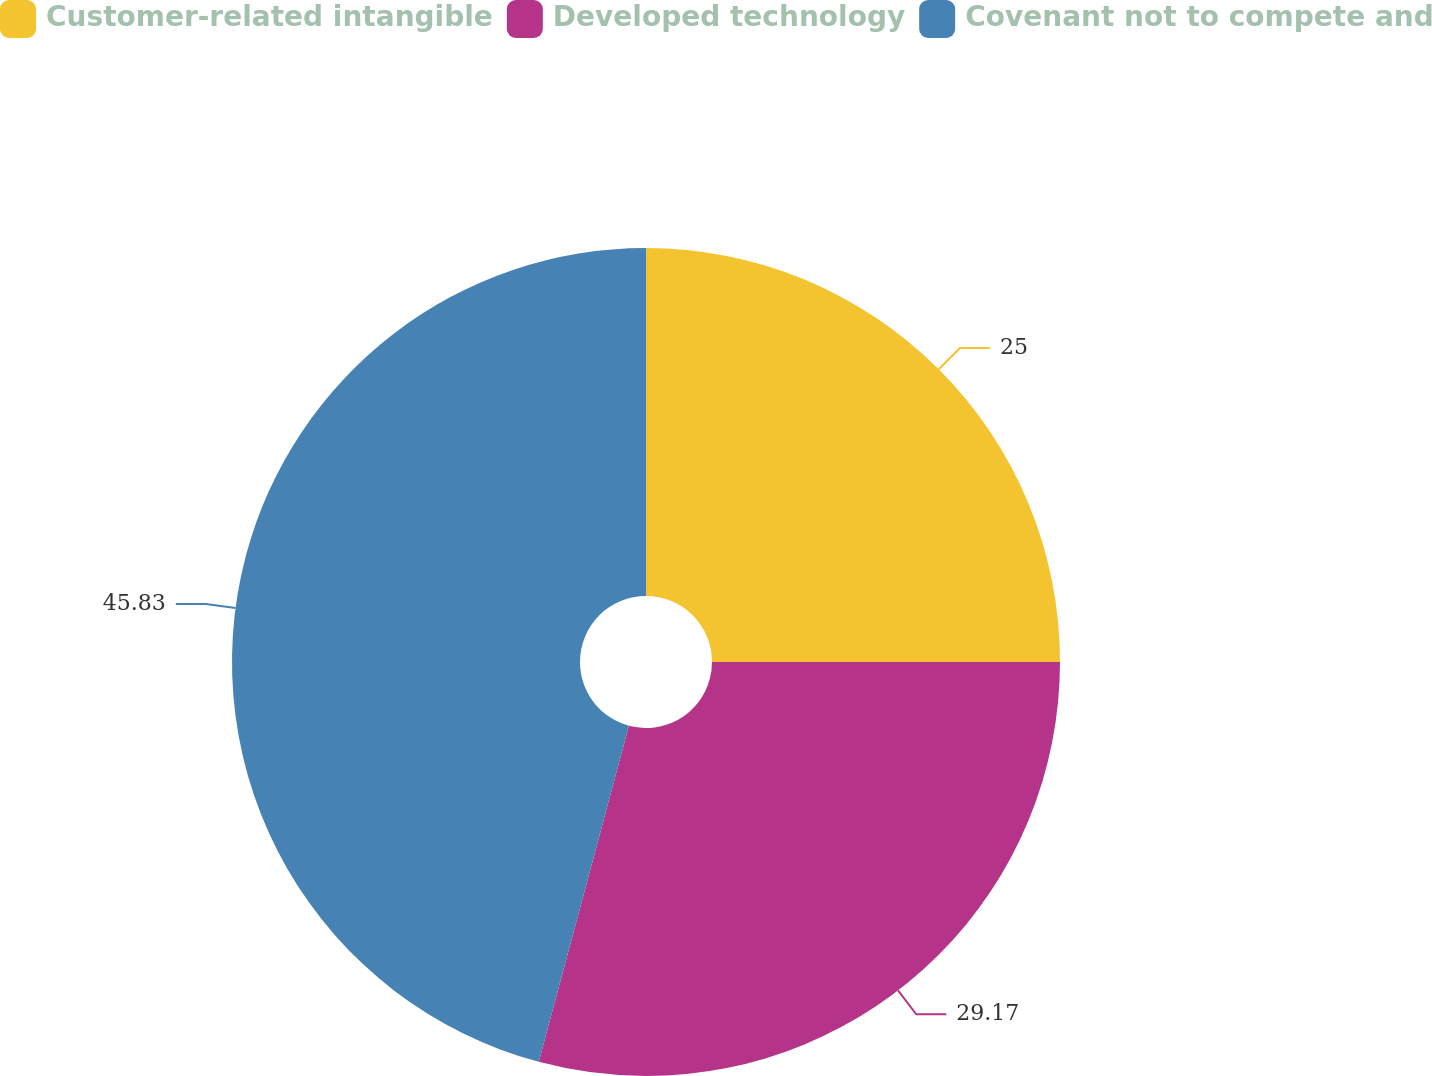Convert chart. <chart><loc_0><loc_0><loc_500><loc_500><pie_chart><fcel>Customer-related intangible<fcel>Developed technology<fcel>Covenant not to compete and<nl><fcel>25.0%<fcel>29.17%<fcel>45.83%<nl></chart> 